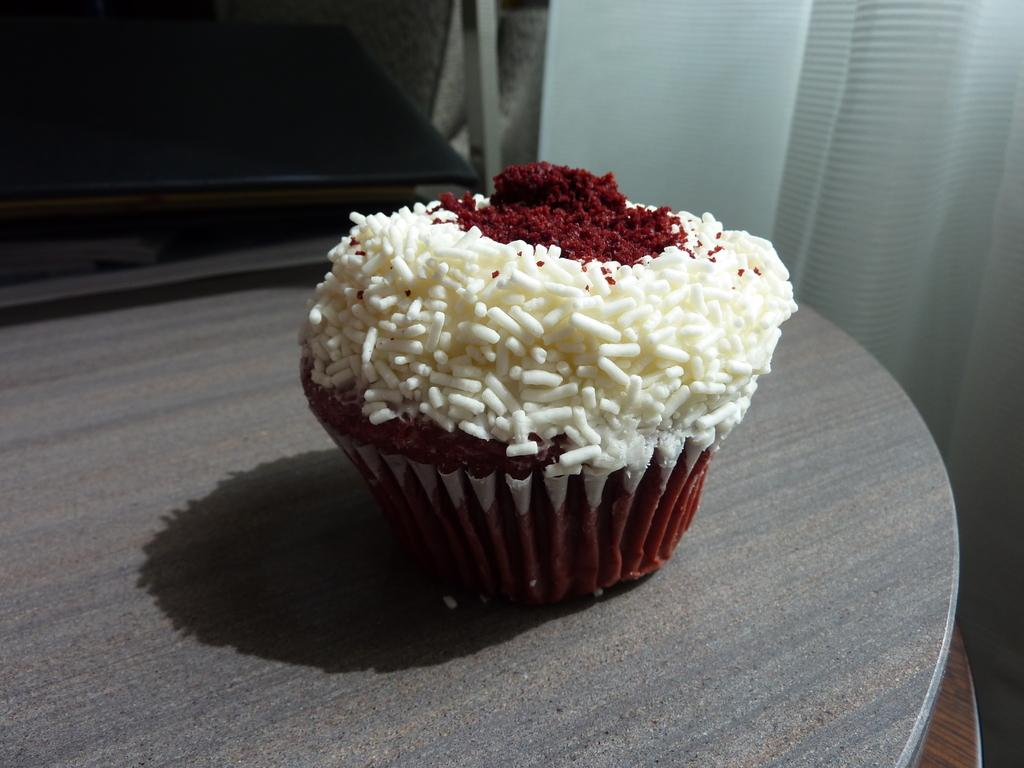What type of dessert is in the image? There is a cupcake in the image. What is the color of the table the cupcake is on? The table is grey. What colors are present on the cupcake? The cupcake has white and maroon colors. What colors are used in the background of the image? The background of the image is in white and black colors. Do the fairies in the image believe in the power of the whip? There are no fairies present in the image, and therefore, the question cannot be answered. 